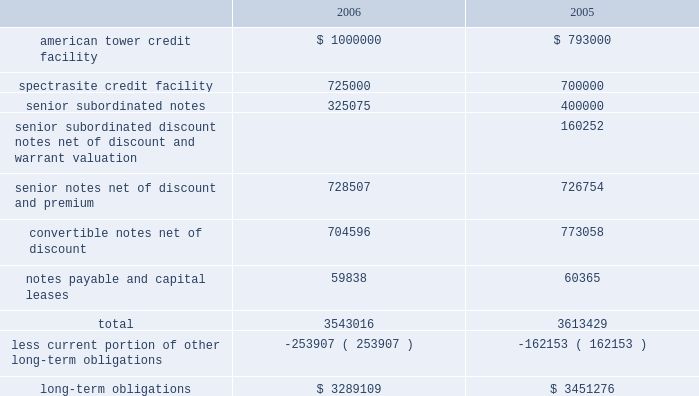American tower corporation and subsidiaries notes to consolidated financial statements 2014 ( continued ) 7 .
Financing arrangements outstanding amounts under the company 2019s long-term financing arrangements consisted of the following as of december 31 , ( in thousands ) : .
Credit facilities 2014in october 2005 , the company refinanced the two existing credit facilities of its principal operating subsidiaries .
The company replaced the existing american tower $ 1.1 billion senior secured credit facility with a new $ 1.3 billion senior secured credit facility and replaced the existing spectrasite $ 900.0 million senior secured credit facility with a new $ 1.15 billion senior secured credit facility .
In february 2007 , the company secured an additional $ 550.0 million under its credit facilities and drew down $ 250.0 million of the existing revolving loans under the american tower credit facility .
( see note 19. ) during the year ended december 31 , 2006 , the company drew down the remaining amount available under the delayed draw term loan component of the american tower credit facility and drew down $ 25.0 million of the delayed draw term loan component of the spectrasite credit facility to finance debt redemptions and repurchases .
In addition , on october 27 , 2006 , the remaining $ 175.0 million undrawn portion of the delayed draw term loan component of the spectrasite facility was canceled pursuant to its terms .
As of december 31 , 2006 , the american tower credit facility consists of the following : 2022 a $ 300.0 million revolving credit facility , against which approximately $ 17.8 million of undrawn letters of credit are outstanding at december 31 , 2006 , maturing on october 27 , 2010 ; 2022 a $ 750.0 million term loan a , which is fully drawn , maturing on october 27 , 2010 ; and 2022 a $ 250.0 million delayed draw term loan , which is fully drawn , maturing on october 27 , 2010 .
The borrowers under the american tower credit facility include ati , american tower , l.p. , american tower international , inc .
And american tower llc .
The company and the borrowers 2019 restricted subsidiaries ( as defined in the loan agreement ) have guaranteed all of the loans under the credit facility .
These loans are secured by liens on and security interests in substantially all assets of the borrowers and the restricted subsidiaries , with a carrying value aggregating approximately $ 4.5 billion at december 31 , 2006 .
As of december 31 , 2006 , the spectrasite credit facility consists of the following : 2022 a $ 250.0 million revolving credit facility , against which approximately $ 4.6 million of undrawn letters of credit were outstanding at december 31 , 2006 , maturing on october 27 , 2010; .
What percentage of outstanding amounts under the company 2019s long-term financing arrangements is current as of december 31 , 2005? 
Computations: (162153 / 3613429)
Answer: 0.04488. 